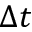<formula> <loc_0><loc_0><loc_500><loc_500>\Delta t</formula> 